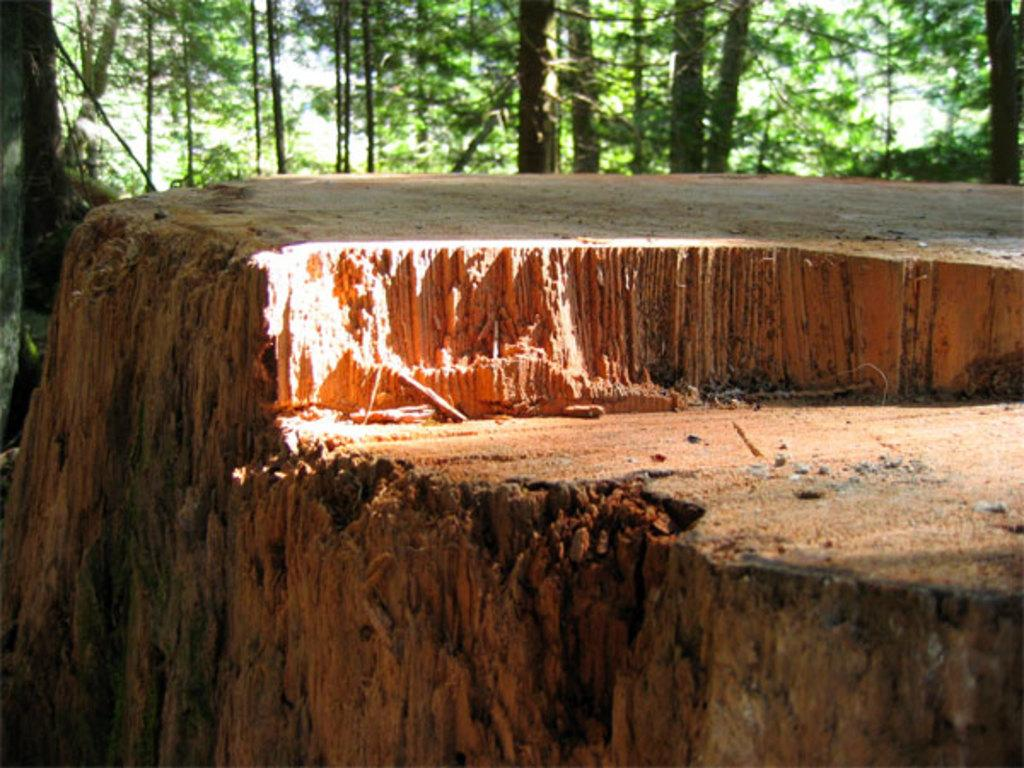What object is the main focus of the image? There is a wooden trunk in the image. What can be seen in the background of the image? There are trees in the background of the image. What type of jam is being spread on the wooden trunk in the image? There is no jam or any indication of spreading in the image; it only features a wooden trunk and trees in the background. 